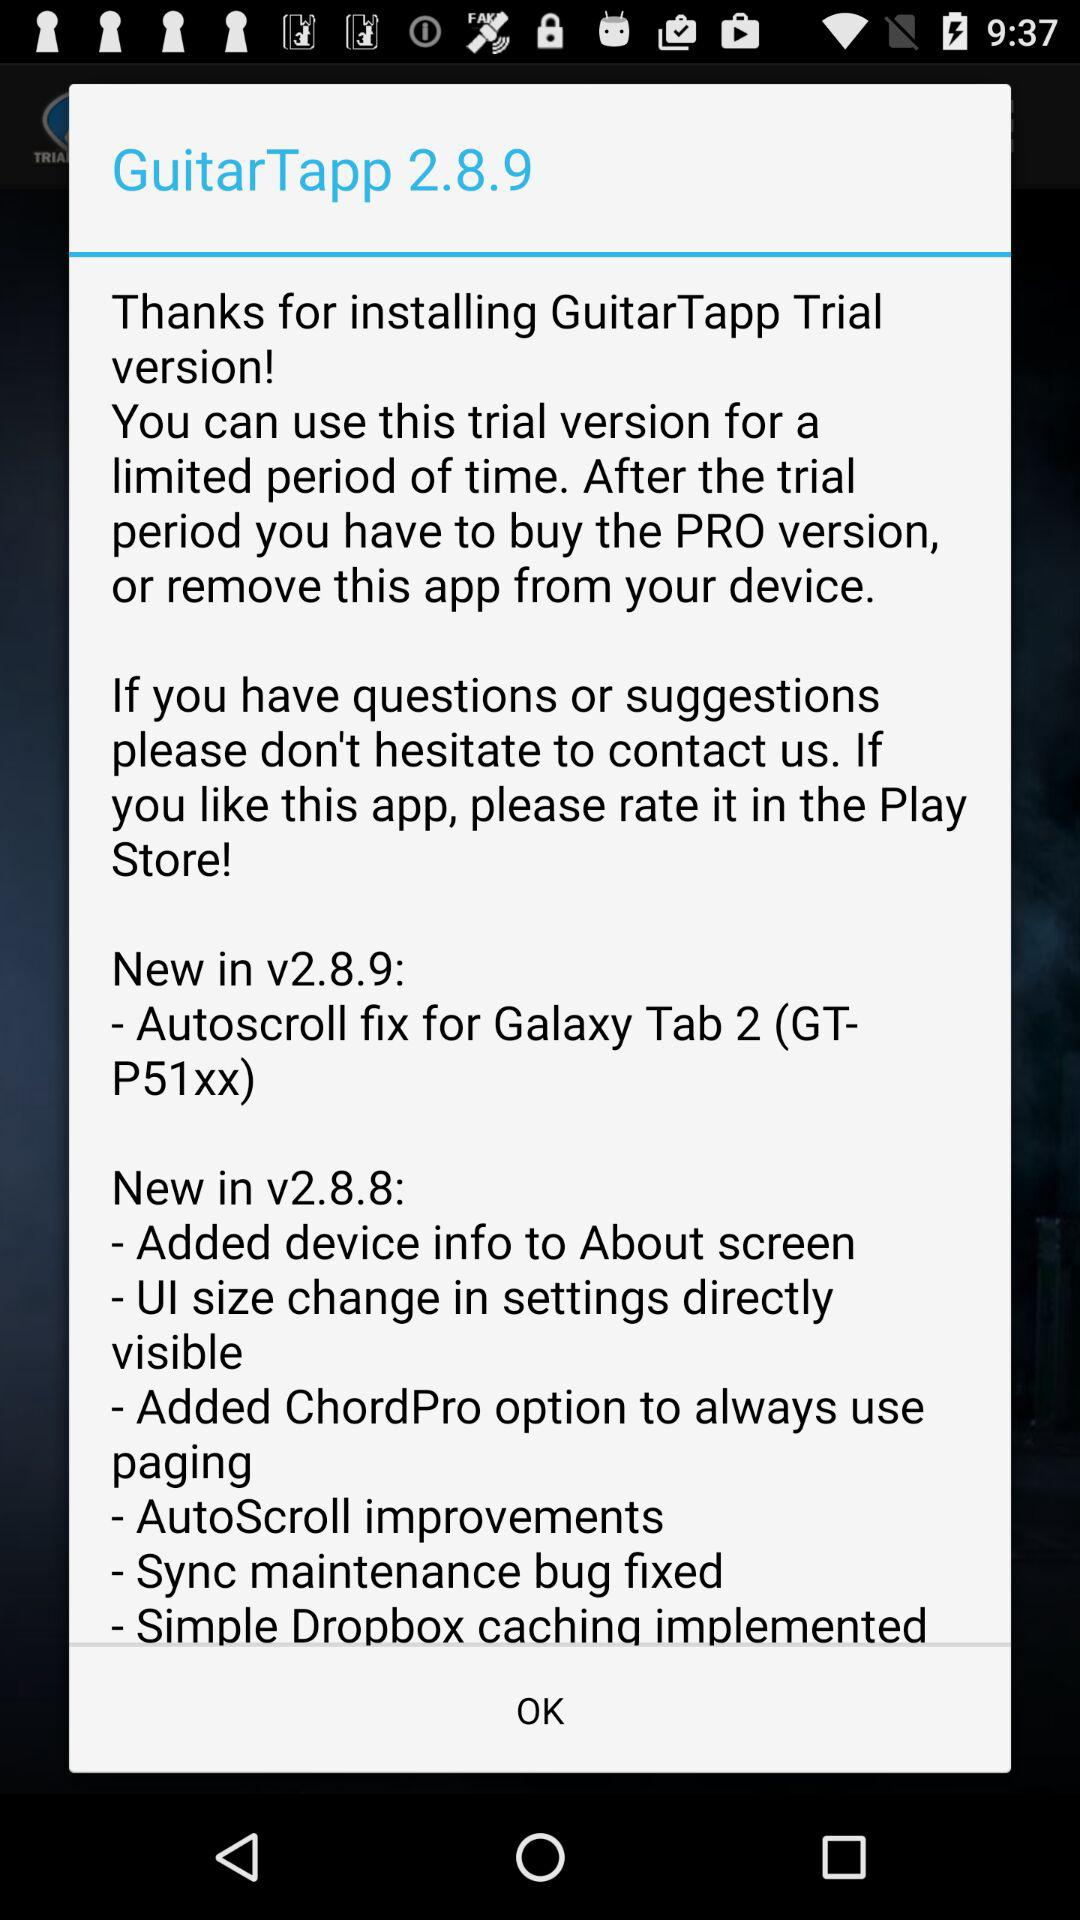What are the features of "New in v2.8.8"? The features are "Added device info to About screen", "UI size change in settings directly visible", "Added ChordPro options to always use paging", "AutoScroll improvements", "Sync maintenance bug fixed", and "Simple Dropbox caching implemented". 